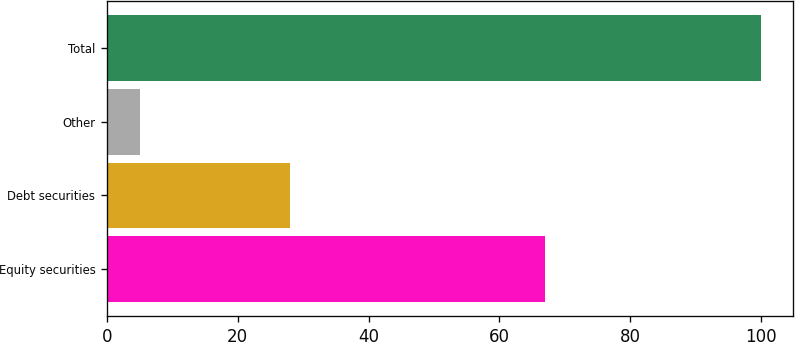Convert chart. <chart><loc_0><loc_0><loc_500><loc_500><bar_chart><fcel>Equity securities<fcel>Debt securities<fcel>Other<fcel>Total<nl><fcel>67<fcel>28<fcel>5<fcel>100<nl></chart> 